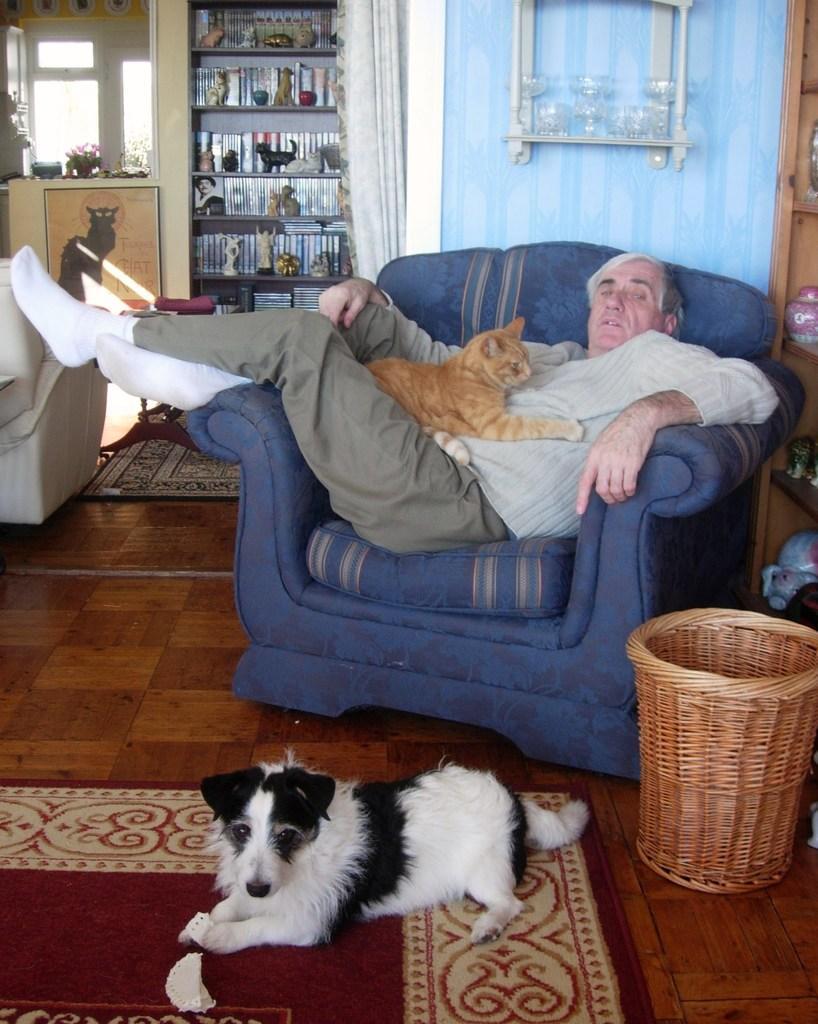How would you summarize this image in a sentence or two? In this image we can see a person sitting on a sofa chair. On the person there is a cat. On the floor there are carpets. On the carpet there is a dog. Near to that there is a wooden basket. Also there is a wall with an object. Also we can see a cupboard with some items. In the background there is curtain. Also there is a cupboard with statues of some items and some other objects. In the background we can see glass walls. Also there is a wall with a photo frame. 